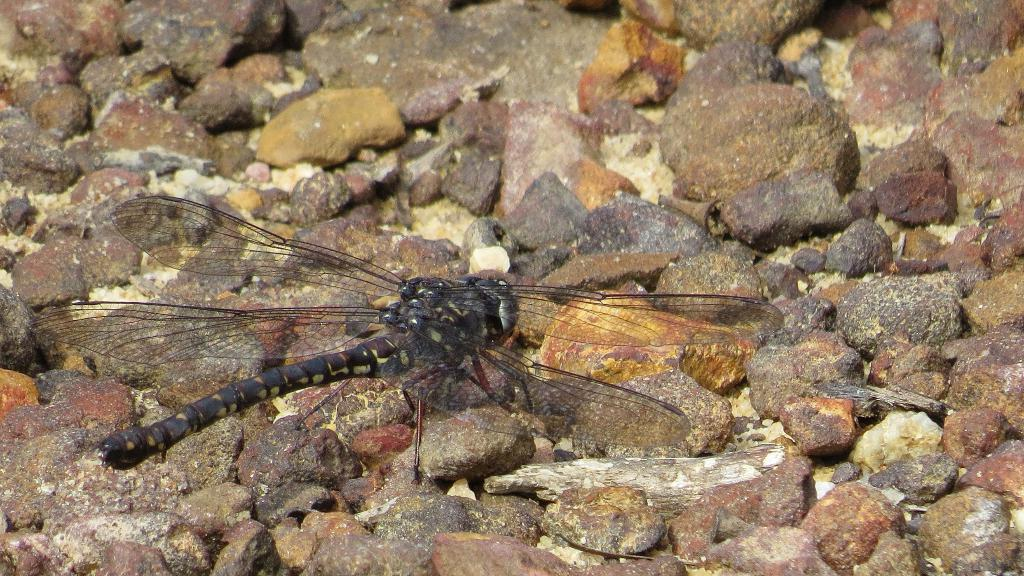What is the main subject in the center of the image? There is an insect in the center of the image. What else can be seen in the image besides the insect? There are stones in the image. How many members are on the team in the image? There is no team present in the image. What is the grandmother doing in the image? There is no grandmother present in the image. What tasks does the servant perform in the image? There is no servant present in the image. 